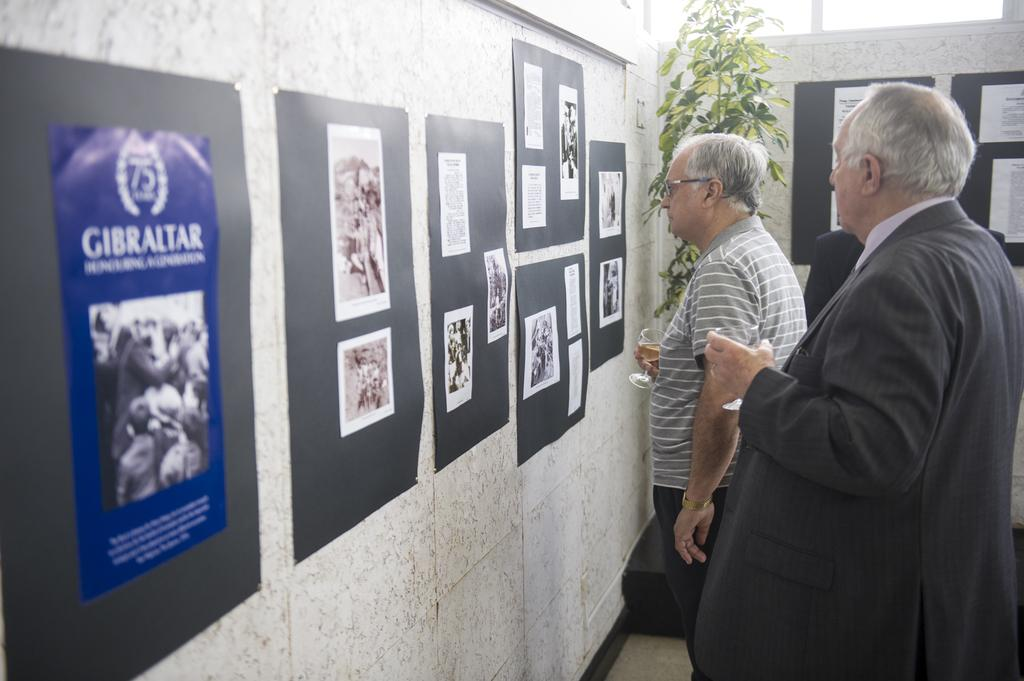What can be seen on the right side of the image? There are people standing on the right side of the image. What are the people holding in their hands? The people are holding wine glasses. What is on the wall in the image? There are posters on the wall. What is visible in the background of the image? There is a plant and a wall in the background of the image. Reasoning: Let's think step by step by step in order to produce the conversation. We start by identifying the main subjects in the image, which are the people standing on the right side. Then, we describe what the people are holding, which are wine glasses. Next, we mention the posters on the wall and the plant and wall in the background. Each question is designed to elicit a specific detail about the image that is known from the provided facts. Absurd Question/Answer: What is the name of the desk in the image? There is no desk present in the image. What mark can be seen on the wall in the image? There is no mark visible on the wall in the image. What is the name of the desk in the image? There is no desk present in the image. What mark can be seen on the wall in the image? There is no mark visible on the wall in the image. 